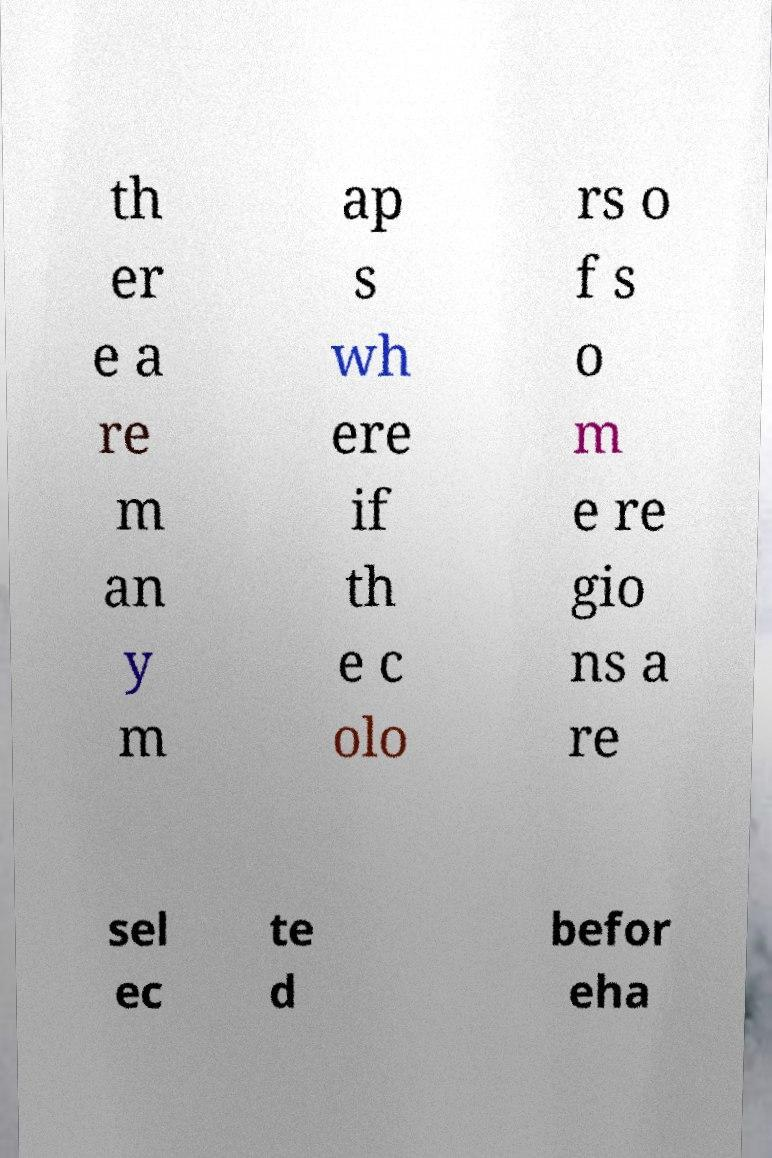Could you extract and type out the text from this image? th er e a re m an y m ap s wh ere if th e c olo rs o f s o m e re gio ns a re sel ec te d befor eha 